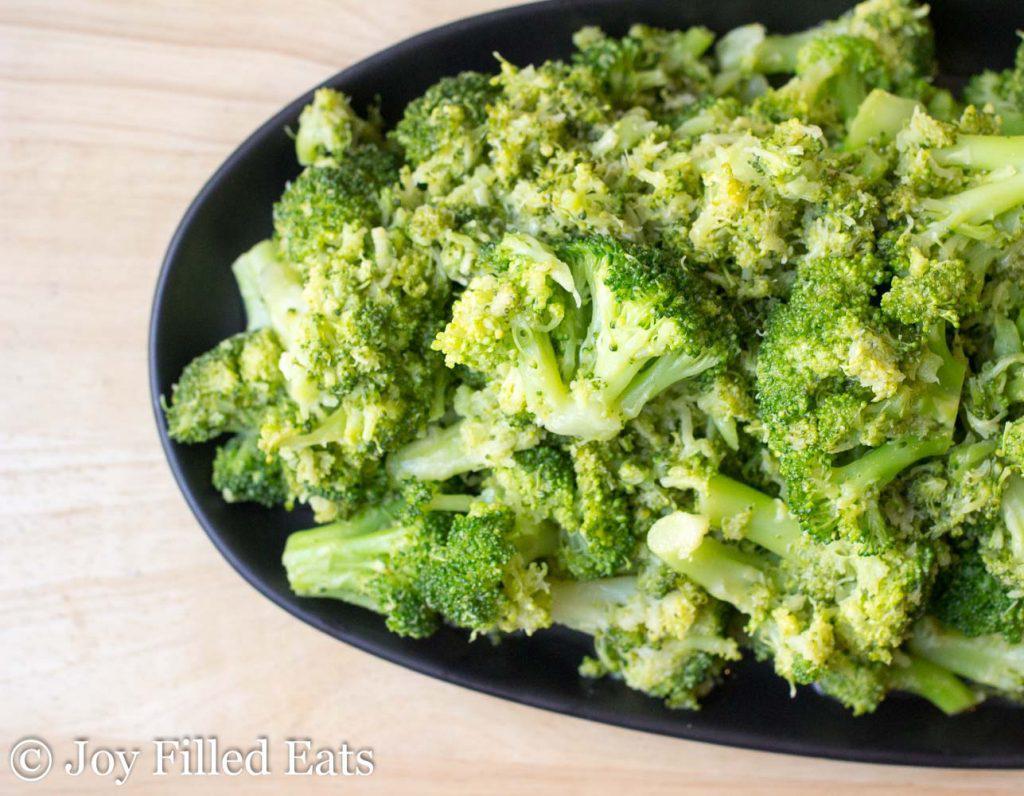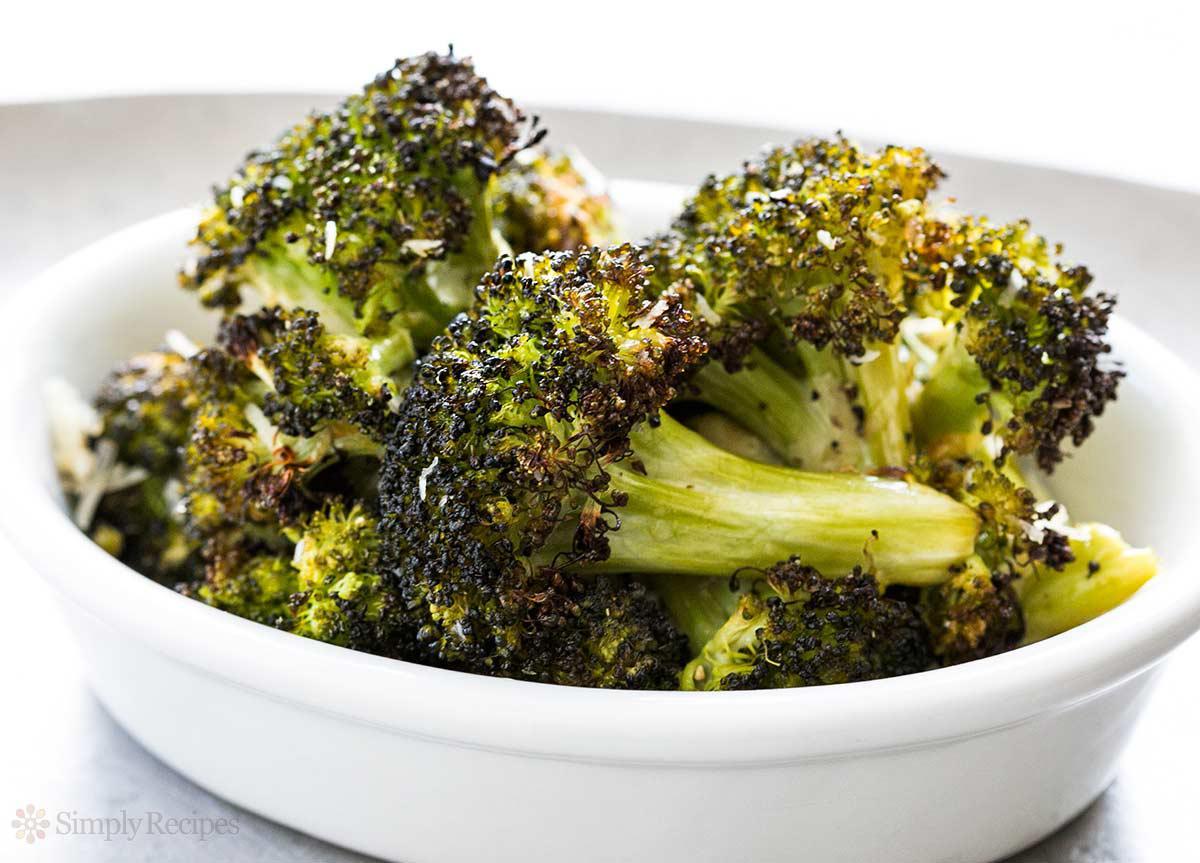The first image is the image on the left, the second image is the image on the right. Considering the images on both sides, is "The left and right image contains a total two white plates with broccoli." valid? Answer yes or no. No. The first image is the image on the left, the second image is the image on the right. Assess this claim about the two images: "Each image shows broccoli florets in a white container, and one image shows broccoli florets in an oblong-shaped bowl.". Correct or not? Answer yes or no. No. 